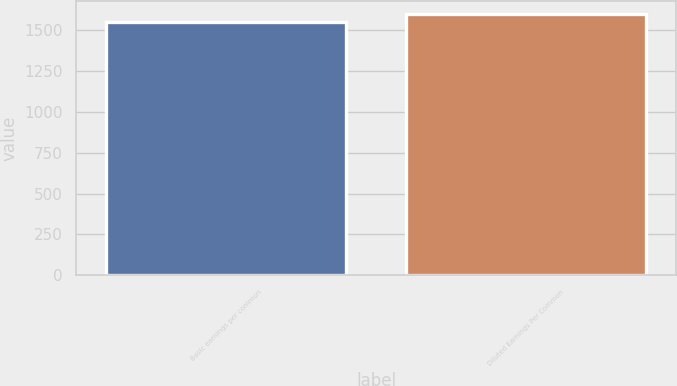<chart> <loc_0><loc_0><loc_500><loc_500><bar_chart><fcel>Basic earnings per common<fcel>Diluted Earnings Per Common<nl><fcel>1550<fcel>1594<nl></chart> 